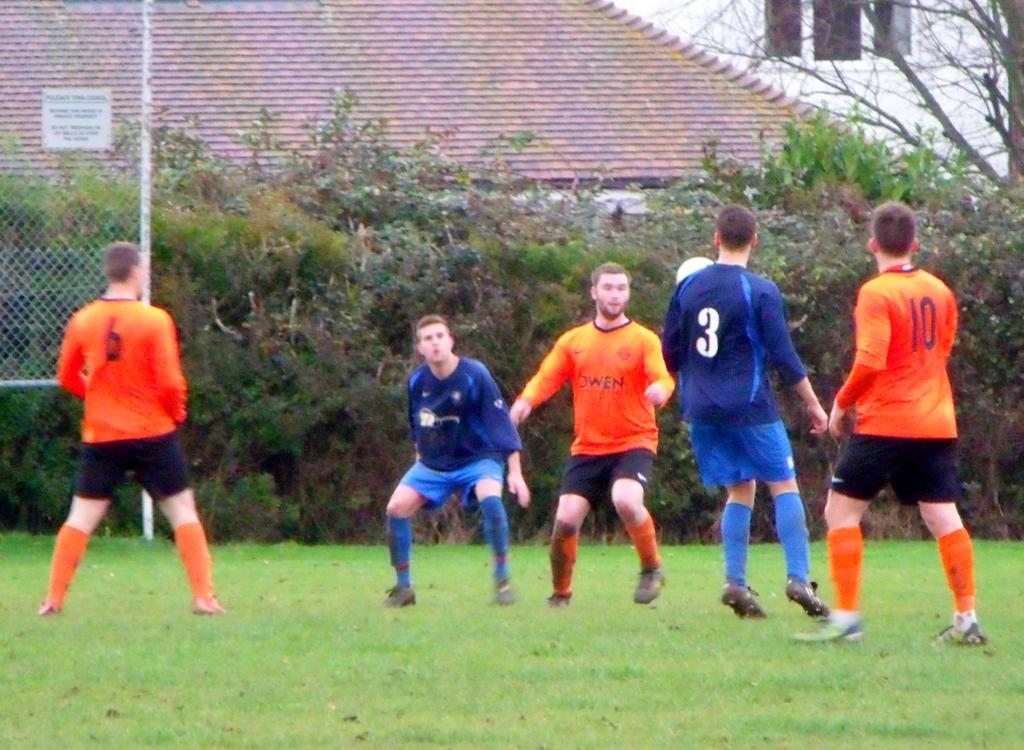<image>
Describe the image concisely. Male soccer players with a number three in blue. 